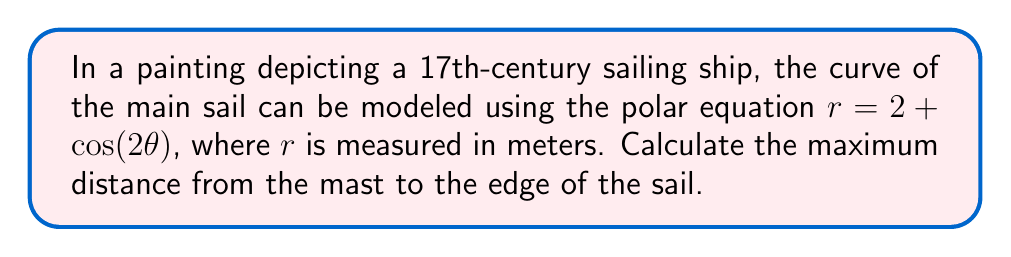Help me with this question. To find the maximum distance from the mast to the edge of the sail, we need to determine the maximum value of $r$ in the given polar equation.

1) The equation of the sail is given by:
   $$r = 2 + \cos(2\theta)$$

2) The maximum value of $r$ will occur when $\cos(2\theta)$ is at its maximum. We know that the maximum value of cosine is 1.

3) Therefore, the maximum value of $r$ is:
   $$r_{max} = 2 + 1 = 3$$

4) This occurs when $\cos(2\theta) = 1$, which happens when $2\theta = 0, 2\pi, 4\pi,$ etc., or when $\theta = 0, \pi, 2\pi,$ etc.

5) We can visualize this curve using the following Asymptote diagram:

[asy]
import graph;
size(200);
real r(real t) {return 2+cos(2*t);}
draw(polargraph(r,0,2*pi,operator ..),red);
draw(circle((0,0),3),blue+dashed);
draw((0,0)--(3,0),Arrow);
label("$r_{max}$",(1.5,0),N);
dot((0,0));
label("Mast",(0,0),SW);
[/asy]

The blue dashed circle represents the maximum reach of the sail, and the red curve shows the shape of the sail.
Answer: The maximum distance from the mast to the edge of the sail is 3 meters. 